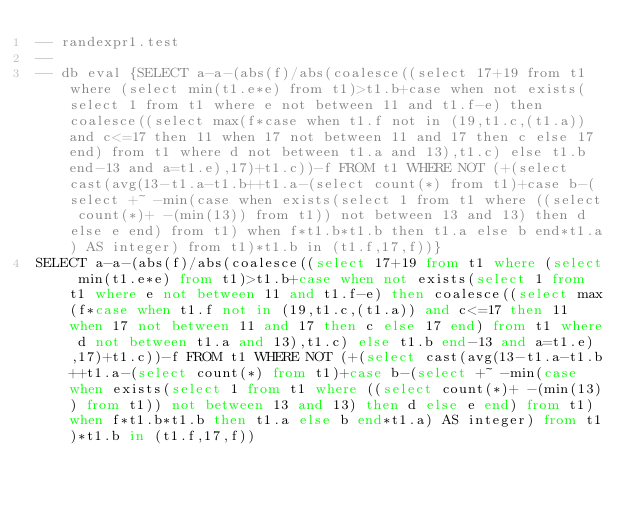Convert code to text. <code><loc_0><loc_0><loc_500><loc_500><_SQL_>-- randexpr1.test
-- 
-- db eval {SELECT a-a-(abs(f)/abs(coalesce((select 17+19 from t1 where (select min(t1.e*e) from t1)>t1.b+case when not exists(select 1 from t1 where e not between 11 and t1.f-e) then coalesce((select max(f*case when t1.f not in (19,t1.c,(t1.a)) and c<=17 then 11 when 17 not between 11 and 17 then c else 17 end) from t1 where d not between t1.a and 13),t1.c) else t1.b end-13 and a=t1.e),17)+t1.c))-f FROM t1 WHERE NOT (+(select cast(avg(13-t1.a-t1.b++t1.a-(select count(*) from t1)+case b-(select +~ -min(case when exists(select 1 from t1 where ((select count(*)+ -(min(13)) from t1)) not between 13 and 13) then d else e end) from t1) when f*t1.b*t1.b then t1.a else b end*t1.a) AS integer) from t1)*t1.b in (t1.f,17,f))}
SELECT a-a-(abs(f)/abs(coalesce((select 17+19 from t1 where (select min(t1.e*e) from t1)>t1.b+case when not exists(select 1 from t1 where e not between 11 and t1.f-e) then coalesce((select max(f*case when t1.f not in (19,t1.c,(t1.a)) and c<=17 then 11 when 17 not between 11 and 17 then c else 17 end) from t1 where d not between t1.a and 13),t1.c) else t1.b end-13 and a=t1.e),17)+t1.c))-f FROM t1 WHERE NOT (+(select cast(avg(13-t1.a-t1.b++t1.a-(select count(*) from t1)+case b-(select +~ -min(case when exists(select 1 from t1 where ((select count(*)+ -(min(13)) from t1)) not between 13 and 13) then d else e end) from t1) when f*t1.b*t1.b then t1.a else b end*t1.a) AS integer) from t1)*t1.b in (t1.f,17,f))</code> 